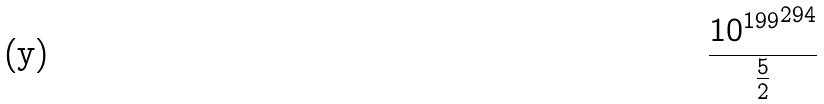Convert formula to latex. <formula><loc_0><loc_0><loc_500><loc_500>\frac { { 1 0 ^ { 1 9 9 } } ^ { 2 9 4 } } { \frac { 5 } { 2 } }</formula> 